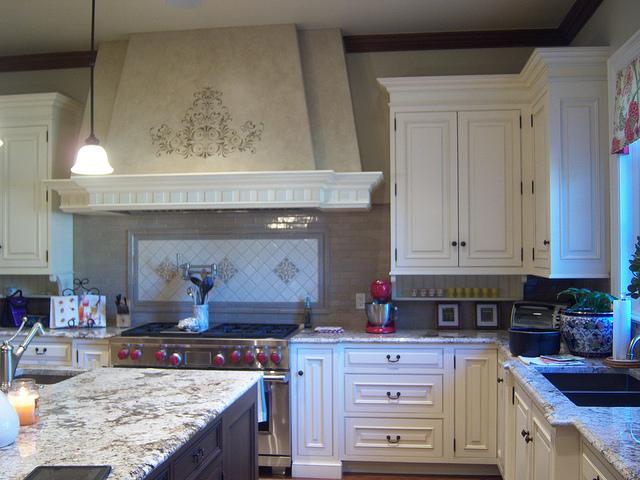What are the counters made of?
Concise answer only. Granite. What room was this picture taken?
Be succinct. Kitchen. Is this a modern kitchen?
Give a very brief answer. Yes. Is this bathroom elegant?
Be succinct. No. 